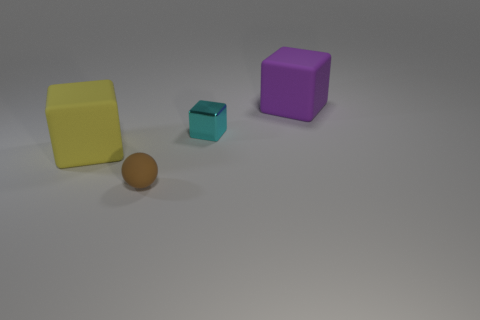There is another big thing that is the same shape as the yellow matte thing; what is its color?
Ensure brevity in your answer.  Purple. How big is the yellow matte object?
Provide a succinct answer. Large. What color is the big object that is on the right side of the object that is in front of the large yellow matte block?
Offer a terse response. Purple. What number of objects are both behind the brown ball and on the left side of the small cyan shiny object?
Provide a succinct answer. 1. Is the number of yellow matte objects greater than the number of big green metal balls?
Offer a very short reply. Yes. What is the material of the cyan cube?
Provide a succinct answer. Metal. There is a big block in front of the cyan block; how many blocks are on the right side of it?
Your answer should be compact. 2. There is a matte thing that is the same size as the purple rubber cube; what color is it?
Make the answer very short. Yellow. Are there any big yellow things that have the same shape as the big purple matte thing?
Your answer should be very brief. Yes. Is the number of large purple shiny cylinders less than the number of things?
Offer a terse response. Yes. 